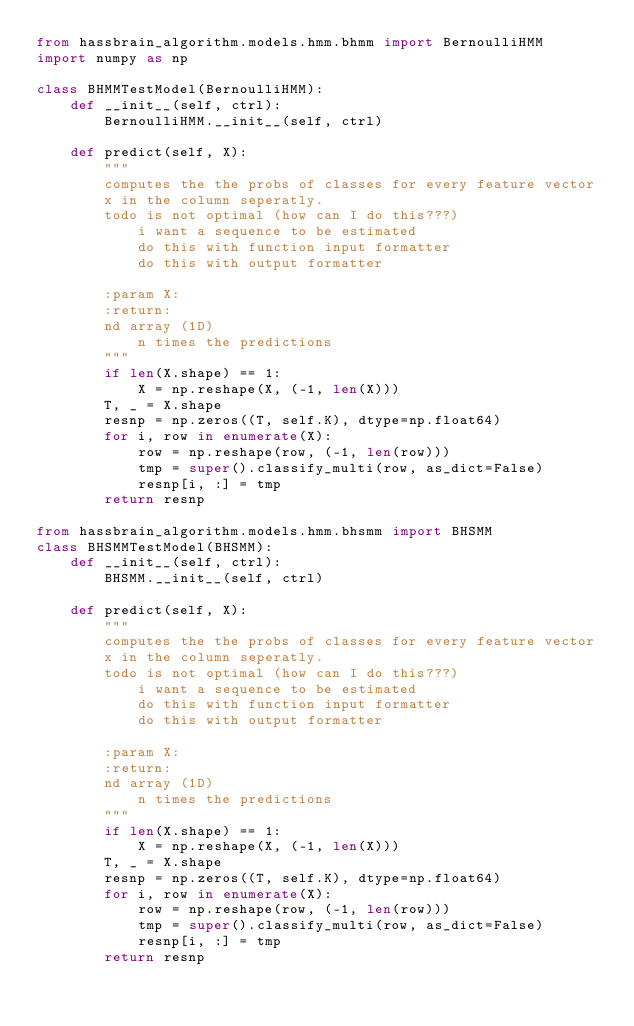Convert code to text. <code><loc_0><loc_0><loc_500><loc_500><_Python_>from hassbrain_algorithm.models.hmm.bhmm import BernoulliHMM
import numpy as np

class BHMMTestModel(BernoulliHMM):
    def __init__(self, ctrl):
        BernoulliHMM.__init__(self, ctrl)

    def predict(self, X):
        """
        computes the the probs of classes for every feature vector
        x in the column seperatly.
        todo is not optimal (how can I do this???)
            i want a sequence to be estimated
            do this with function input formatter
            do this with output formatter

        :param X:
        :return:
        nd array (1D)
            n times the predictions
        """
        if len(X.shape) == 1:
            X = np.reshape(X, (-1, len(X)))
        T, _ = X.shape
        resnp = np.zeros((T, self.K), dtype=np.float64)
        for i, row in enumerate(X):
            row = np.reshape(row, (-1, len(row)))
            tmp = super().classify_multi(row, as_dict=False)
            resnp[i, :] = tmp
        return resnp

from hassbrain_algorithm.models.hmm.bhsmm import BHSMM
class BHSMMTestModel(BHSMM):
    def __init__(self, ctrl):
        BHSMM.__init__(self, ctrl)

    def predict(self, X):
        """
        computes the the probs of classes for every feature vector
        x in the column seperatly.
        todo is not optimal (how can I do this???)
            i want a sequence to be estimated
            do this with function input formatter
            do this with output formatter

        :param X:
        :return:
        nd array (1D)
            n times the predictions
        """
        if len(X.shape) == 1:
            X = np.reshape(X, (-1, len(X)))
        T, _ = X.shape
        resnp = np.zeros((T, self.K), dtype=np.float64)
        for i, row in enumerate(X):
            row = np.reshape(row, (-1, len(row)))
            tmp = super().classify_multi(row, as_dict=False)
            resnp[i, :] = tmp
        return resnp
</code> 